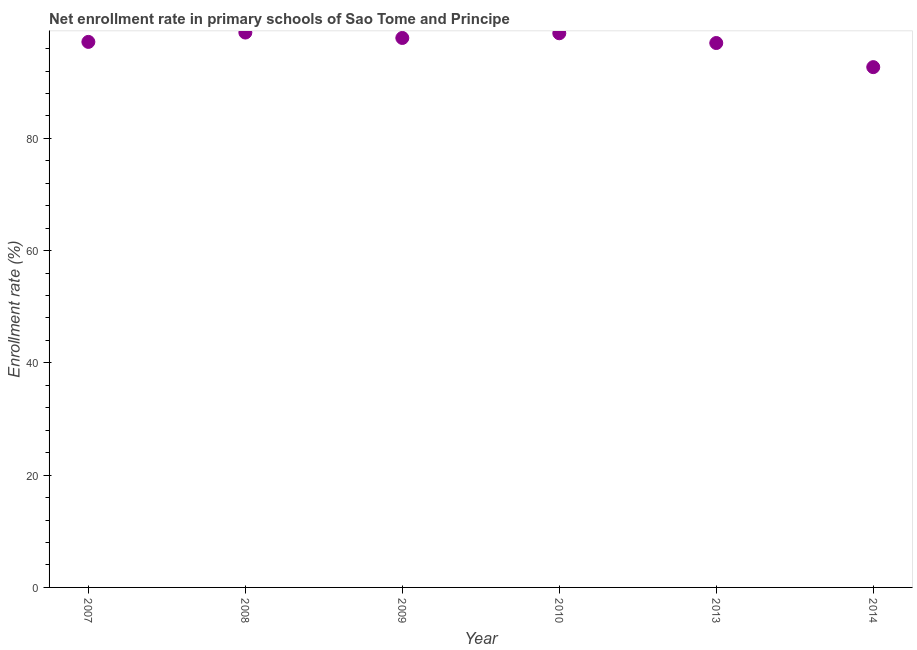What is the net enrollment rate in primary schools in 2014?
Your answer should be very brief. 92.69. Across all years, what is the maximum net enrollment rate in primary schools?
Keep it short and to the point. 98.85. Across all years, what is the minimum net enrollment rate in primary schools?
Give a very brief answer. 92.69. What is the sum of the net enrollment rate in primary schools?
Make the answer very short. 582.32. What is the difference between the net enrollment rate in primary schools in 2007 and 2010?
Provide a short and direct response. -1.54. What is the average net enrollment rate in primary schools per year?
Offer a terse response. 97.05. What is the median net enrollment rate in primary schools?
Ensure brevity in your answer.  97.54. Do a majority of the years between 2009 and 2007 (inclusive) have net enrollment rate in primary schools greater than 20 %?
Your answer should be compact. No. What is the ratio of the net enrollment rate in primary schools in 2010 to that in 2013?
Offer a very short reply. 1.02. Is the difference between the net enrollment rate in primary schools in 2009 and 2010 greater than the difference between any two years?
Provide a short and direct response. No. What is the difference between the highest and the second highest net enrollment rate in primary schools?
Provide a succinct answer. 0.13. Is the sum of the net enrollment rate in primary schools in 2008 and 2014 greater than the maximum net enrollment rate in primary schools across all years?
Provide a short and direct response. Yes. What is the difference between the highest and the lowest net enrollment rate in primary schools?
Your answer should be compact. 6.16. Does the net enrollment rate in primary schools monotonically increase over the years?
Make the answer very short. No. How many dotlines are there?
Offer a very short reply. 1. What is the difference between two consecutive major ticks on the Y-axis?
Provide a short and direct response. 20. Are the values on the major ticks of Y-axis written in scientific E-notation?
Give a very brief answer. No. What is the title of the graph?
Provide a short and direct response. Net enrollment rate in primary schools of Sao Tome and Principe. What is the label or title of the X-axis?
Offer a very short reply. Year. What is the label or title of the Y-axis?
Offer a very short reply. Enrollment rate (%). What is the Enrollment rate (%) in 2007?
Your response must be concise. 97.19. What is the Enrollment rate (%) in 2008?
Provide a short and direct response. 98.85. What is the Enrollment rate (%) in 2009?
Offer a terse response. 97.89. What is the Enrollment rate (%) in 2010?
Make the answer very short. 98.72. What is the Enrollment rate (%) in 2013?
Your answer should be compact. 96.99. What is the Enrollment rate (%) in 2014?
Ensure brevity in your answer.  92.69. What is the difference between the Enrollment rate (%) in 2007 and 2008?
Give a very brief answer. -1.66. What is the difference between the Enrollment rate (%) in 2007 and 2009?
Provide a short and direct response. -0.7. What is the difference between the Enrollment rate (%) in 2007 and 2010?
Give a very brief answer. -1.54. What is the difference between the Enrollment rate (%) in 2007 and 2013?
Your answer should be very brief. 0.2. What is the difference between the Enrollment rate (%) in 2007 and 2014?
Give a very brief answer. 4.5. What is the difference between the Enrollment rate (%) in 2008 and 2009?
Provide a succinct answer. 0.96. What is the difference between the Enrollment rate (%) in 2008 and 2010?
Provide a short and direct response. 0.13. What is the difference between the Enrollment rate (%) in 2008 and 2013?
Ensure brevity in your answer.  1.86. What is the difference between the Enrollment rate (%) in 2008 and 2014?
Your answer should be compact. 6.16. What is the difference between the Enrollment rate (%) in 2009 and 2010?
Provide a short and direct response. -0.84. What is the difference between the Enrollment rate (%) in 2009 and 2013?
Your answer should be compact. 0.9. What is the difference between the Enrollment rate (%) in 2009 and 2014?
Ensure brevity in your answer.  5.2. What is the difference between the Enrollment rate (%) in 2010 and 2013?
Your answer should be very brief. 1.74. What is the difference between the Enrollment rate (%) in 2010 and 2014?
Give a very brief answer. 6.03. What is the difference between the Enrollment rate (%) in 2013 and 2014?
Your answer should be very brief. 4.3. What is the ratio of the Enrollment rate (%) in 2007 to that in 2009?
Offer a terse response. 0.99. What is the ratio of the Enrollment rate (%) in 2007 to that in 2010?
Provide a succinct answer. 0.98. What is the ratio of the Enrollment rate (%) in 2007 to that in 2013?
Offer a terse response. 1. What is the ratio of the Enrollment rate (%) in 2007 to that in 2014?
Offer a very short reply. 1.05. What is the ratio of the Enrollment rate (%) in 2008 to that in 2009?
Offer a terse response. 1.01. What is the ratio of the Enrollment rate (%) in 2008 to that in 2014?
Give a very brief answer. 1.07. What is the ratio of the Enrollment rate (%) in 2009 to that in 2010?
Your response must be concise. 0.99. What is the ratio of the Enrollment rate (%) in 2009 to that in 2014?
Offer a terse response. 1.06. What is the ratio of the Enrollment rate (%) in 2010 to that in 2013?
Offer a very short reply. 1.02. What is the ratio of the Enrollment rate (%) in 2010 to that in 2014?
Make the answer very short. 1.06. What is the ratio of the Enrollment rate (%) in 2013 to that in 2014?
Your response must be concise. 1.05. 